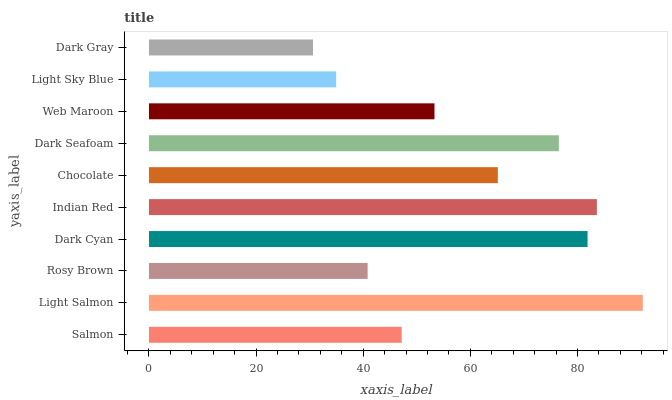Is Dark Gray the minimum?
Answer yes or no. Yes. Is Light Salmon the maximum?
Answer yes or no. Yes. Is Rosy Brown the minimum?
Answer yes or no. No. Is Rosy Brown the maximum?
Answer yes or no. No. Is Light Salmon greater than Rosy Brown?
Answer yes or no. Yes. Is Rosy Brown less than Light Salmon?
Answer yes or no. Yes. Is Rosy Brown greater than Light Salmon?
Answer yes or no. No. Is Light Salmon less than Rosy Brown?
Answer yes or no. No. Is Chocolate the high median?
Answer yes or no. Yes. Is Web Maroon the low median?
Answer yes or no. Yes. Is Dark Seafoam the high median?
Answer yes or no. No. Is Indian Red the low median?
Answer yes or no. No. 